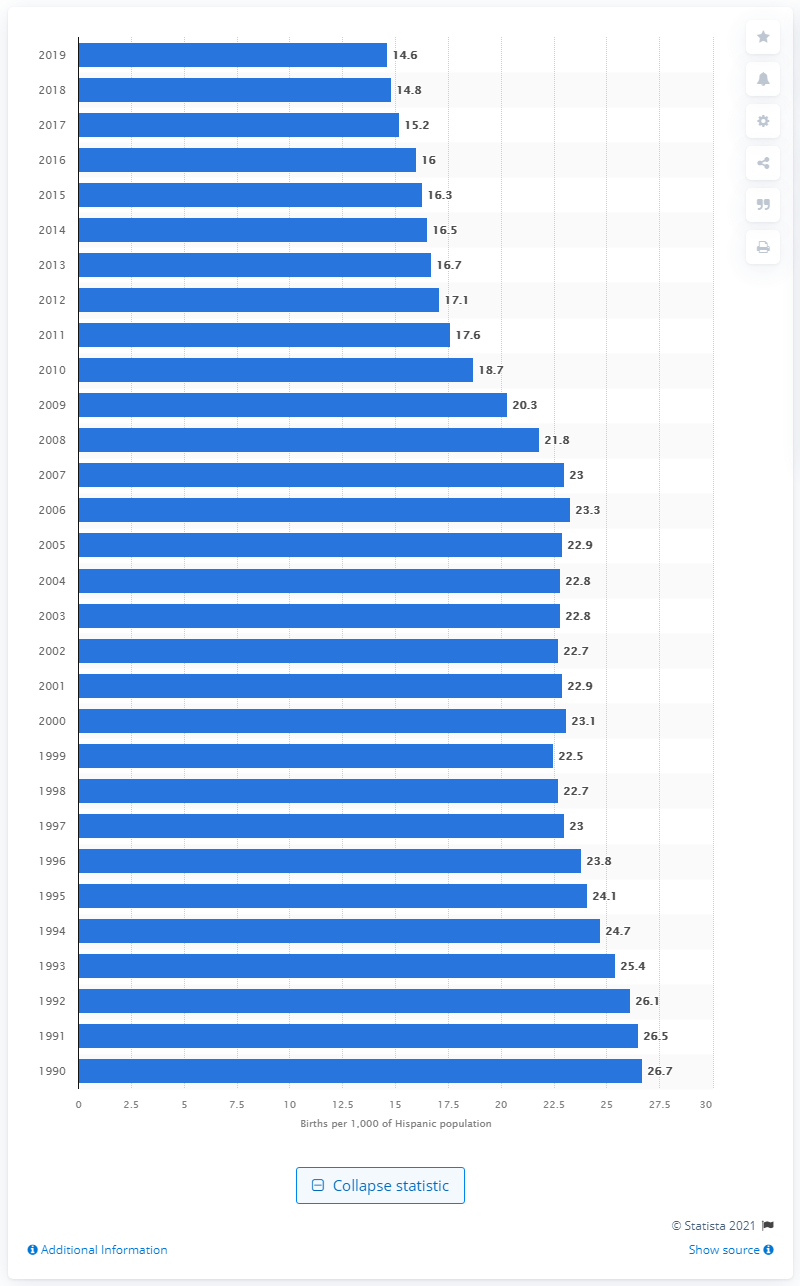Outline some significant characteristics in this image. In 2019, the number of children born per 1,000 Hispanics was 14.6. 